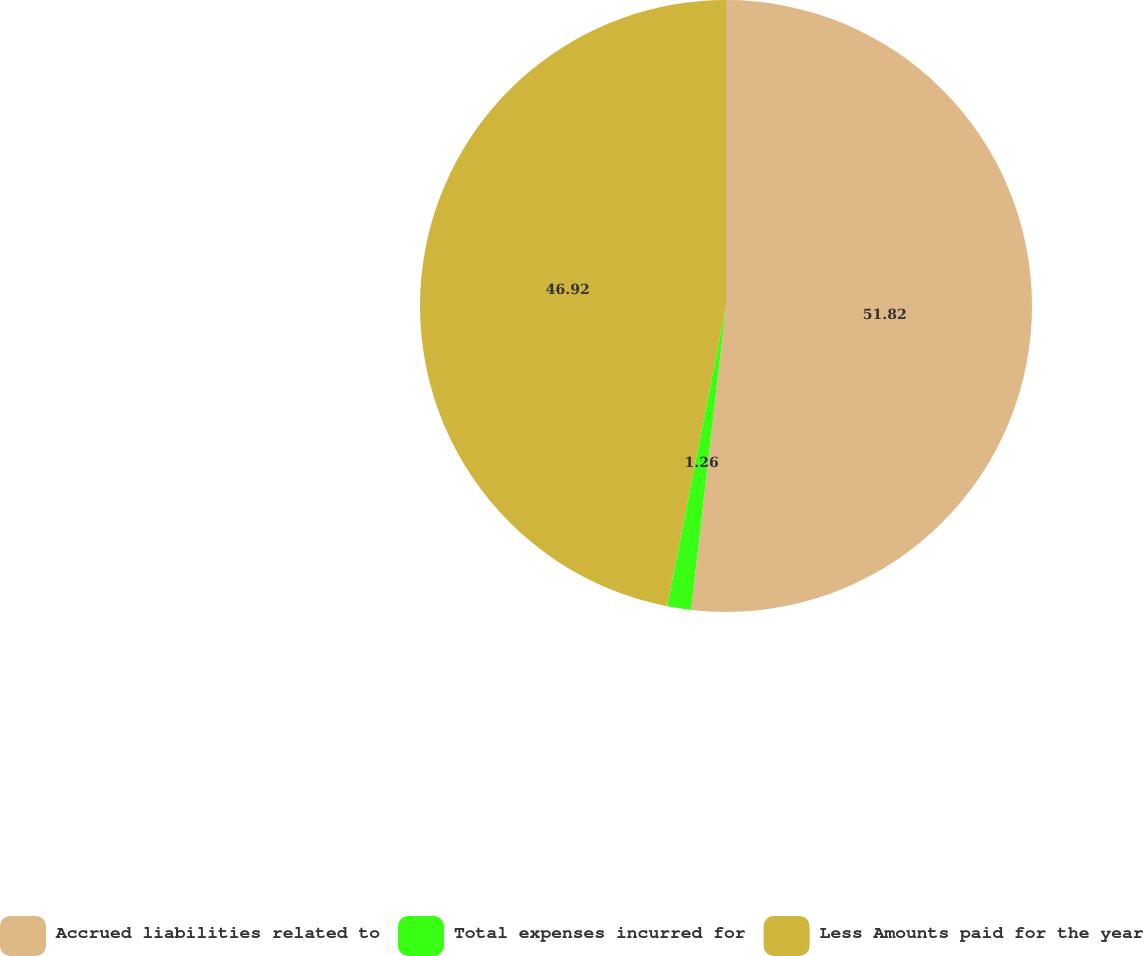Convert chart. <chart><loc_0><loc_0><loc_500><loc_500><pie_chart><fcel>Accrued liabilities related to<fcel>Total expenses incurred for<fcel>Less Amounts paid for the year<nl><fcel>51.82%<fcel>1.26%<fcel>46.92%<nl></chart> 